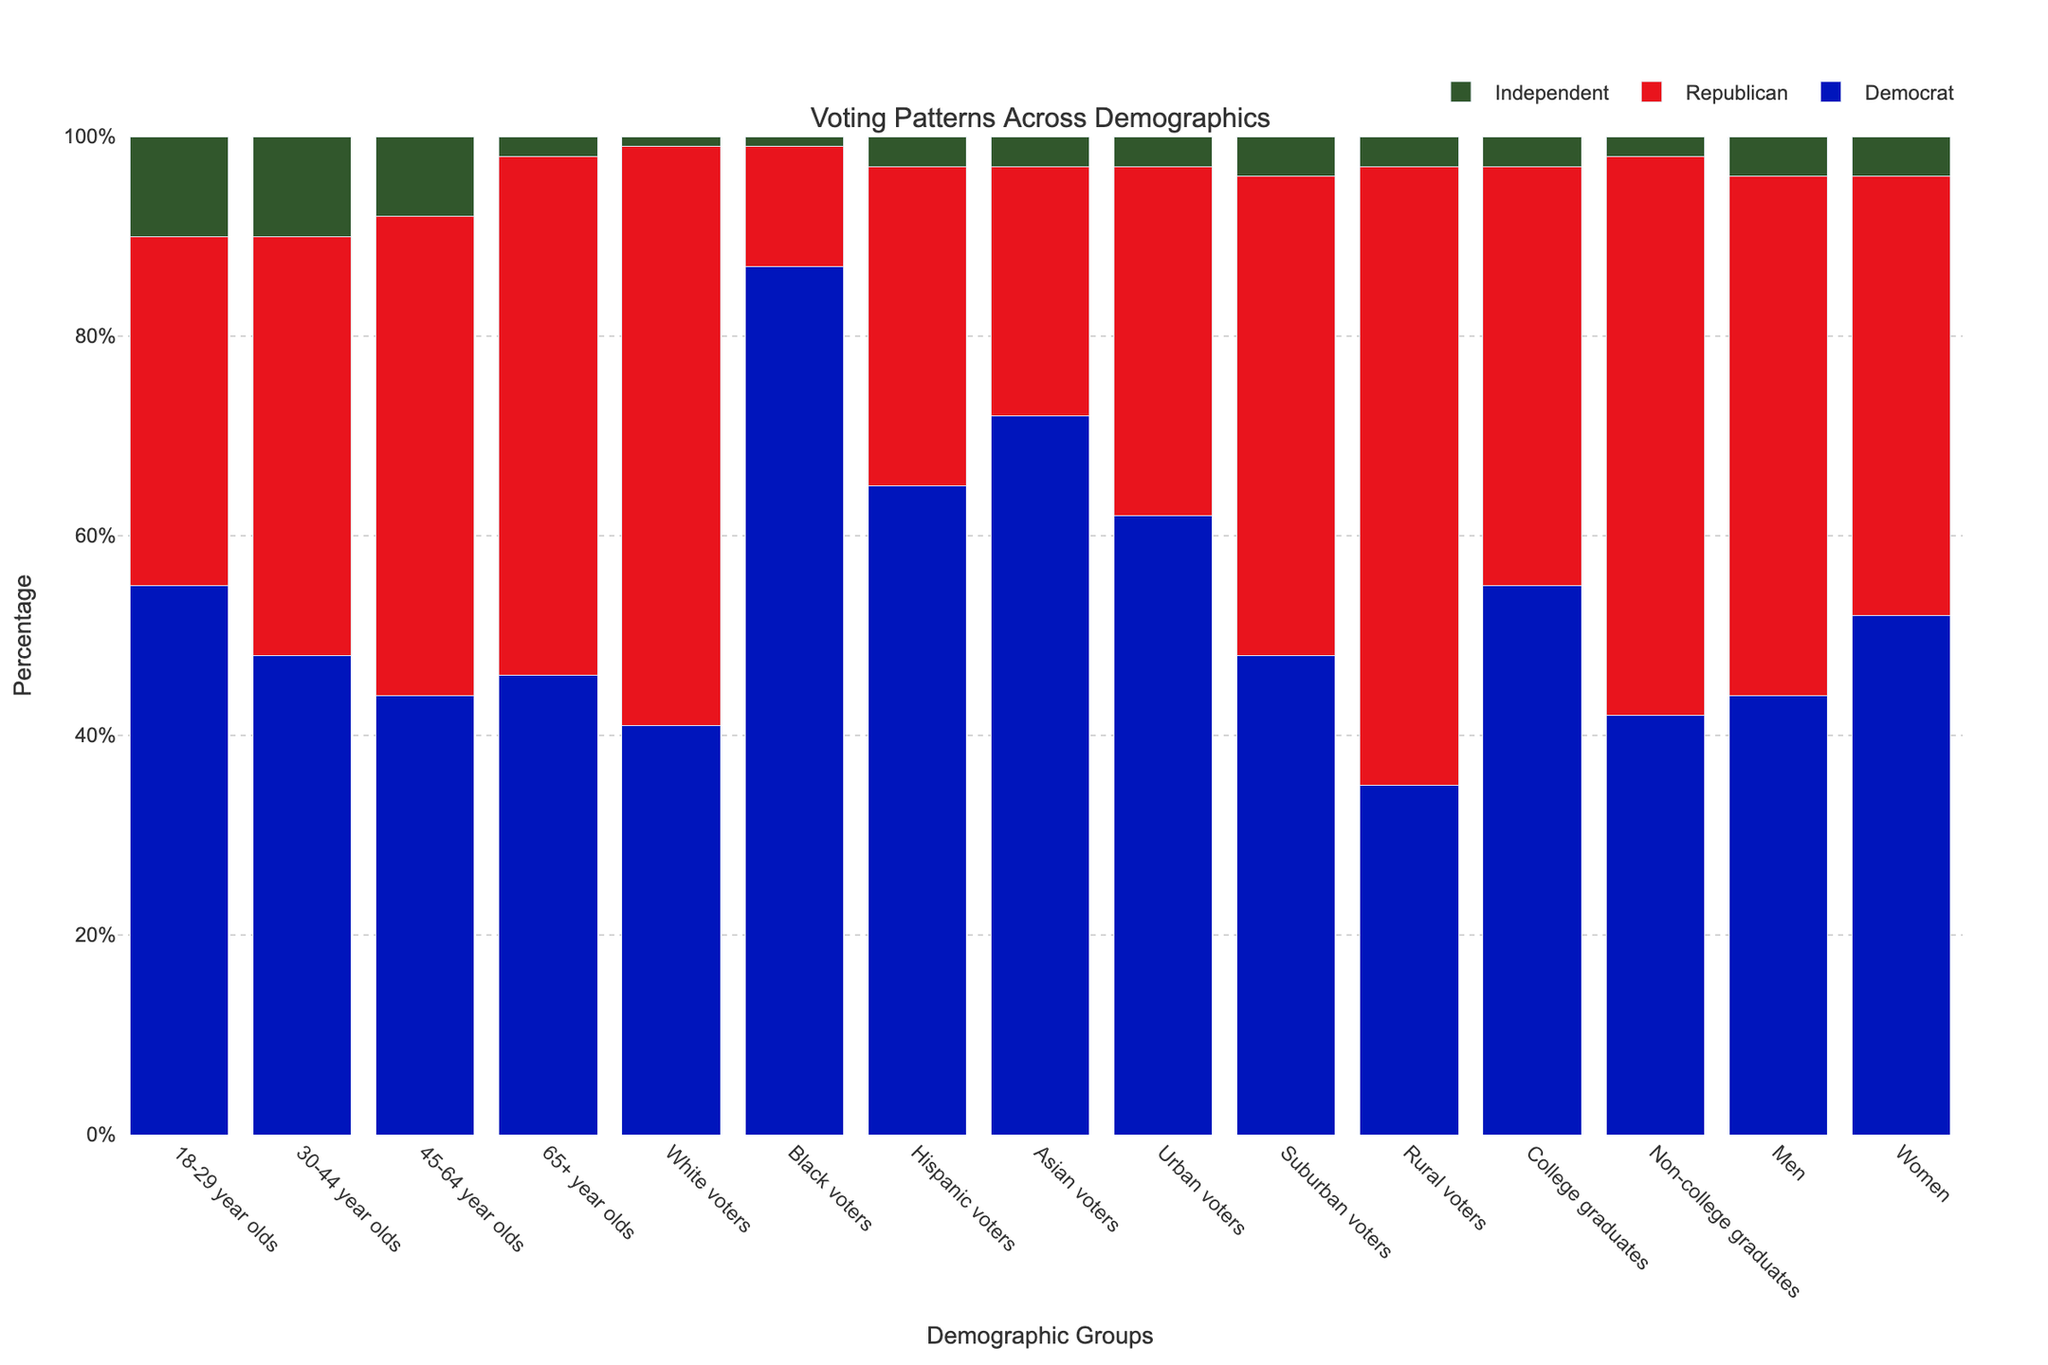What demographic group had the highest percentage of Republican votes? The figure shows different demographic groups with their voting percentages for Democrat, Republican, and Independent. By looking at the heights of the red bars, we can identify the group with the highest percentage. The "White voters" category has the tallest red bar, indicating the highest percentage of Republican votes.
Answer: White voters Which age group had the largest difference between Democrat and Republican votes? To find this, we need to calculate the absolute difference between Democrat and Republican votes for each age group. For "18-29 year olds" (55% - 35% = 20%), "30-44 year olds" (48% - 42% = 6%), "45-64 year olds" (44% - 48% = 4%), and "65+ year olds" (46% - 52% = 6%). The "18-29 year olds" have the largest difference.
Answer: 18-29 year olds How do the voting patterns of "Men" compare to "Women"? We need to compare the percentages for Democrat, Republican, and Independent votes between "Men" and "Women". Men: Democrat (44%), Republican (52%), Independent (4%). Women: Democrat (52%), Republican (44%), Independent (4%). Women have a higher percentage of Democrat votes and a lower percentage of Republican votes compared to men.
Answer: Women have a higher percentage of Democrat votes and a lower percentage of Republican votes What is the total percentage of votes for the "Independent" category across all demographics? Sum the percentage of "Independent" votes for each demographic. 10 + 10 + 8 + 2 + 1 + 1 + 3 + 3 + 3 + 4 + 3 + 3 + 2 + 4 + 4 = 61%.
Answer: 61% Which demographic has the smallest percentage of "Independent" votes? By examining the heights of the green bars representing "Independent" votes, we identify the group with the smallest percentage. The "65+ year olds" and the "White voters" categories both have the smallest, at 1%.
Answer: White voters and 65+ year olds Among "Urban voters," which political group received the most votes? Check the height of each bar within the "Urban voters" category. The blue bar (Democrat) is the tallest, representing 62%.
Answer: Democrat Are "College graduates" more likely to vote for Democrats or Republicans? Compare the heights of the blue (Democrat) and red (Republican) bars within the "College graduates" category. The blue bar is taller, representing 55% compared to 42% for Republicans.
Answer: Democrats What is the average percentage of Democrat votes for all age groups? Sum the Democrat percentages for "18-29 year olds" (55%), "30-44 year olds" (48%), "45-64 year olds" (44%), and "65+ year olds" (46%), then divide by 4. (55 + 48 + 44 + 46) / 4 = 193 / 4 = 48.25%.
Answer: 48.25% Which demographic has the closest percentage of votes for Democrats and Republicans? Find the demographics where the gap between Democrat and Republican votes is smallest. "Suburban voters" have an equal percentage for Democrats and Republicans (48% each).
Answer: Suburban voters 